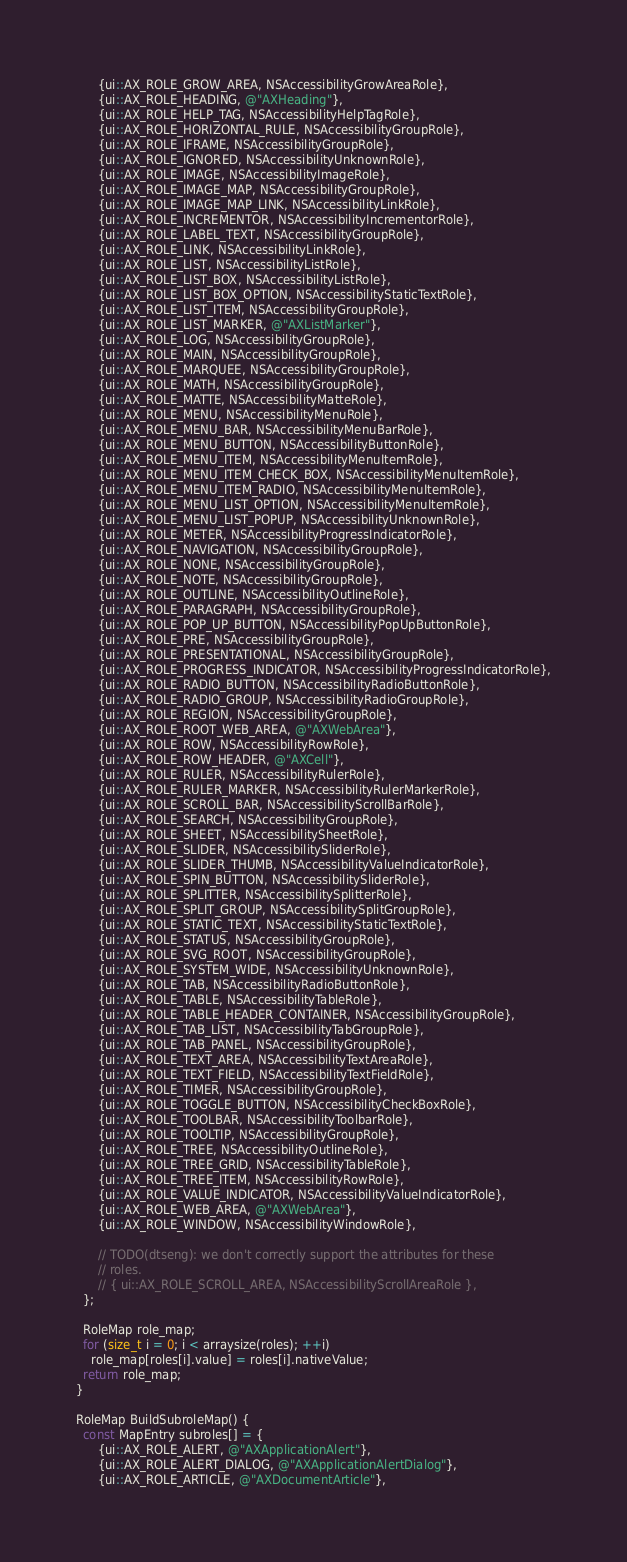<code> <loc_0><loc_0><loc_500><loc_500><_ObjectiveC_>      {ui::AX_ROLE_GROW_AREA, NSAccessibilityGrowAreaRole},
      {ui::AX_ROLE_HEADING, @"AXHeading"},
      {ui::AX_ROLE_HELP_TAG, NSAccessibilityHelpTagRole},
      {ui::AX_ROLE_HORIZONTAL_RULE, NSAccessibilityGroupRole},
      {ui::AX_ROLE_IFRAME, NSAccessibilityGroupRole},
      {ui::AX_ROLE_IGNORED, NSAccessibilityUnknownRole},
      {ui::AX_ROLE_IMAGE, NSAccessibilityImageRole},
      {ui::AX_ROLE_IMAGE_MAP, NSAccessibilityGroupRole},
      {ui::AX_ROLE_IMAGE_MAP_LINK, NSAccessibilityLinkRole},
      {ui::AX_ROLE_INCREMENTOR, NSAccessibilityIncrementorRole},
      {ui::AX_ROLE_LABEL_TEXT, NSAccessibilityGroupRole},
      {ui::AX_ROLE_LINK, NSAccessibilityLinkRole},
      {ui::AX_ROLE_LIST, NSAccessibilityListRole},
      {ui::AX_ROLE_LIST_BOX, NSAccessibilityListRole},
      {ui::AX_ROLE_LIST_BOX_OPTION, NSAccessibilityStaticTextRole},
      {ui::AX_ROLE_LIST_ITEM, NSAccessibilityGroupRole},
      {ui::AX_ROLE_LIST_MARKER, @"AXListMarker"},
      {ui::AX_ROLE_LOG, NSAccessibilityGroupRole},
      {ui::AX_ROLE_MAIN, NSAccessibilityGroupRole},
      {ui::AX_ROLE_MARQUEE, NSAccessibilityGroupRole},
      {ui::AX_ROLE_MATH, NSAccessibilityGroupRole},
      {ui::AX_ROLE_MATTE, NSAccessibilityMatteRole},
      {ui::AX_ROLE_MENU, NSAccessibilityMenuRole},
      {ui::AX_ROLE_MENU_BAR, NSAccessibilityMenuBarRole},
      {ui::AX_ROLE_MENU_BUTTON, NSAccessibilityButtonRole},
      {ui::AX_ROLE_MENU_ITEM, NSAccessibilityMenuItemRole},
      {ui::AX_ROLE_MENU_ITEM_CHECK_BOX, NSAccessibilityMenuItemRole},
      {ui::AX_ROLE_MENU_ITEM_RADIO, NSAccessibilityMenuItemRole},
      {ui::AX_ROLE_MENU_LIST_OPTION, NSAccessibilityMenuItemRole},
      {ui::AX_ROLE_MENU_LIST_POPUP, NSAccessibilityUnknownRole},
      {ui::AX_ROLE_METER, NSAccessibilityProgressIndicatorRole},
      {ui::AX_ROLE_NAVIGATION, NSAccessibilityGroupRole},
      {ui::AX_ROLE_NONE, NSAccessibilityGroupRole},
      {ui::AX_ROLE_NOTE, NSAccessibilityGroupRole},
      {ui::AX_ROLE_OUTLINE, NSAccessibilityOutlineRole},
      {ui::AX_ROLE_PARAGRAPH, NSAccessibilityGroupRole},
      {ui::AX_ROLE_POP_UP_BUTTON, NSAccessibilityPopUpButtonRole},
      {ui::AX_ROLE_PRE, NSAccessibilityGroupRole},
      {ui::AX_ROLE_PRESENTATIONAL, NSAccessibilityGroupRole},
      {ui::AX_ROLE_PROGRESS_INDICATOR, NSAccessibilityProgressIndicatorRole},
      {ui::AX_ROLE_RADIO_BUTTON, NSAccessibilityRadioButtonRole},
      {ui::AX_ROLE_RADIO_GROUP, NSAccessibilityRadioGroupRole},
      {ui::AX_ROLE_REGION, NSAccessibilityGroupRole},
      {ui::AX_ROLE_ROOT_WEB_AREA, @"AXWebArea"},
      {ui::AX_ROLE_ROW, NSAccessibilityRowRole},
      {ui::AX_ROLE_ROW_HEADER, @"AXCell"},
      {ui::AX_ROLE_RULER, NSAccessibilityRulerRole},
      {ui::AX_ROLE_RULER_MARKER, NSAccessibilityRulerMarkerRole},
      {ui::AX_ROLE_SCROLL_BAR, NSAccessibilityScrollBarRole},
      {ui::AX_ROLE_SEARCH, NSAccessibilityGroupRole},
      {ui::AX_ROLE_SHEET, NSAccessibilitySheetRole},
      {ui::AX_ROLE_SLIDER, NSAccessibilitySliderRole},
      {ui::AX_ROLE_SLIDER_THUMB, NSAccessibilityValueIndicatorRole},
      {ui::AX_ROLE_SPIN_BUTTON, NSAccessibilitySliderRole},
      {ui::AX_ROLE_SPLITTER, NSAccessibilitySplitterRole},
      {ui::AX_ROLE_SPLIT_GROUP, NSAccessibilitySplitGroupRole},
      {ui::AX_ROLE_STATIC_TEXT, NSAccessibilityStaticTextRole},
      {ui::AX_ROLE_STATUS, NSAccessibilityGroupRole},
      {ui::AX_ROLE_SVG_ROOT, NSAccessibilityGroupRole},
      {ui::AX_ROLE_SYSTEM_WIDE, NSAccessibilityUnknownRole},
      {ui::AX_ROLE_TAB, NSAccessibilityRadioButtonRole},
      {ui::AX_ROLE_TABLE, NSAccessibilityTableRole},
      {ui::AX_ROLE_TABLE_HEADER_CONTAINER, NSAccessibilityGroupRole},
      {ui::AX_ROLE_TAB_LIST, NSAccessibilityTabGroupRole},
      {ui::AX_ROLE_TAB_PANEL, NSAccessibilityGroupRole},
      {ui::AX_ROLE_TEXT_AREA, NSAccessibilityTextAreaRole},
      {ui::AX_ROLE_TEXT_FIELD, NSAccessibilityTextFieldRole},
      {ui::AX_ROLE_TIMER, NSAccessibilityGroupRole},
      {ui::AX_ROLE_TOGGLE_BUTTON, NSAccessibilityCheckBoxRole},
      {ui::AX_ROLE_TOOLBAR, NSAccessibilityToolbarRole},
      {ui::AX_ROLE_TOOLTIP, NSAccessibilityGroupRole},
      {ui::AX_ROLE_TREE, NSAccessibilityOutlineRole},
      {ui::AX_ROLE_TREE_GRID, NSAccessibilityTableRole},
      {ui::AX_ROLE_TREE_ITEM, NSAccessibilityRowRole},
      {ui::AX_ROLE_VALUE_INDICATOR, NSAccessibilityValueIndicatorRole},
      {ui::AX_ROLE_WEB_AREA, @"AXWebArea"},
      {ui::AX_ROLE_WINDOW, NSAccessibilityWindowRole},

      // TODO(dtseng): we don't correctly support the attributes for these
      // roles.
      // { ui::AX_ROLE_SCROLL_AREA, NSAccessibilityScrollAreaRole },
  };

  RoleMap role_map;
  for (size_t i = 0; i < arraysize(roles); ++i)
    role_map[roles[i].value] = roles[i].nativeValue;
  return role_map;
}

RoleMap BuildSubroleMap() {
  const MapEntry subroles[] = {
      {ui::AX_ROLE_ALERT, @"AXApplicationAlert"},
      {ui::AX_ROLE_ALERT_DIALOG, @"AXApplicationAlertDialog"},
      {ui::AX_ROLE_ARTICLE, @"AXDocumentArticle"},</code> 